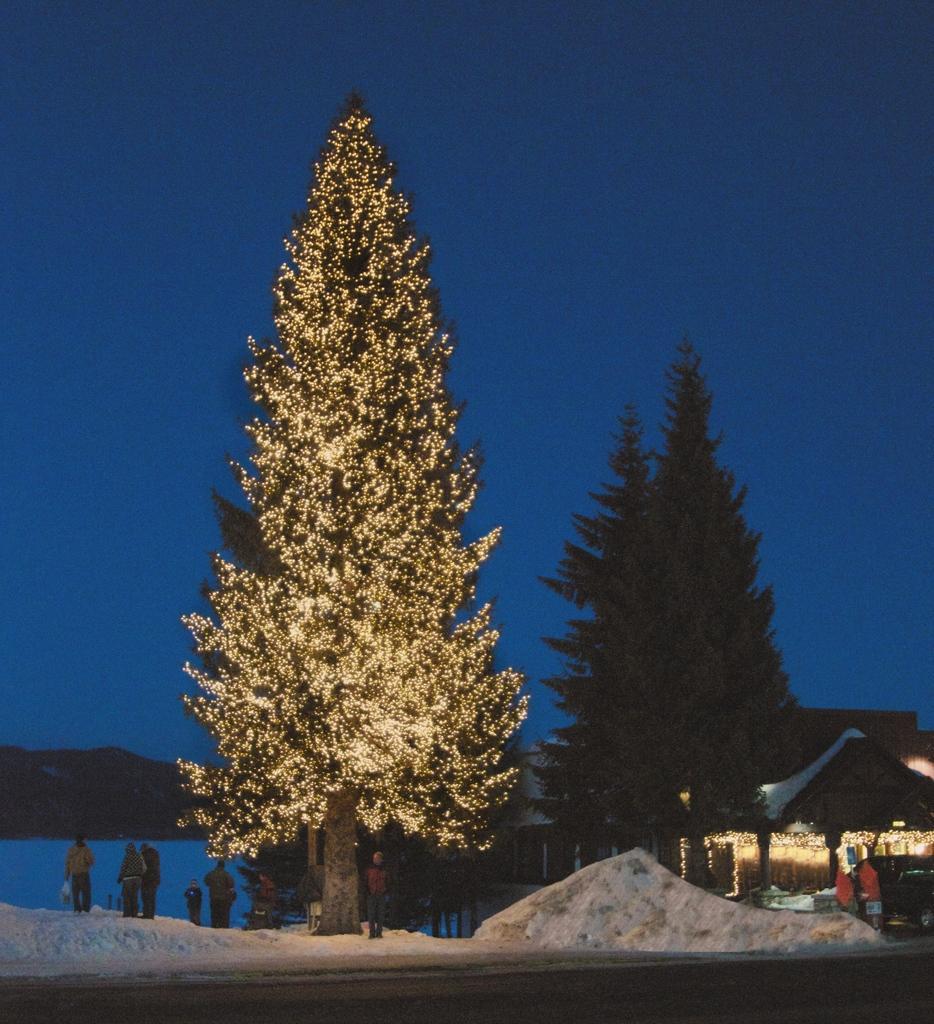Can you describe this image briefly? In this picture I can see a house, there is snow, there are group of people standing, there are trees, there is a tree decorated with lights, and in the background there is sky. 